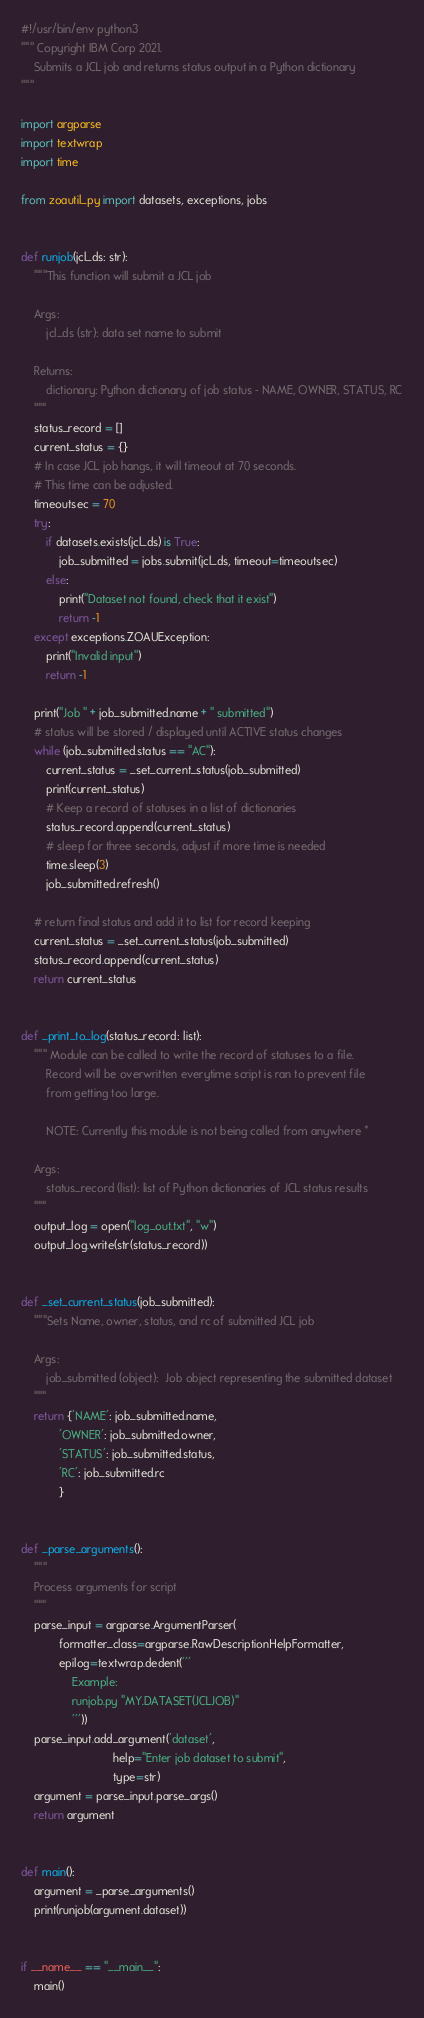Convert code to text. <code><loc_0><loc_0><loc_500><loc_500><_Python_>#!/usr/bin/env python3
""" Copyright IBM Corp 2021.
    Submits a JCL job and returns status output in a Python dictionary
"""

import argparse
import textwrap
import time

from zoautil_py import datasets, exceptions, jobs


def runjob(jcl_ds: str):
    """This function will submit a JCL job

    Args:
        jcl_ds (str): data set name to submit

    Returns:
        dictionary: Python dictionary of job status - NAME, OWNER, STATUS, RC
    """
    status_record = []
    current_status = {}
    # In case JCL job hangs, it will timeout at 70 seconds.
    # This time can be adjusted.
    timeoutsec = 70
    try:
        if datasets.exists(jcl_ds) is True:
            job_submitted = jobs.submit(jcl_ds, timeout=timeoutsec)
        else:
            print("Dataset not found, check that it exist")
            return -1
    except exceptions.ZOAUException:
        print("Invalid input")
        return -1

    print("Job " + job_submitted.name + " submitted")
    # status will be stored / displayed until ACTIVE status changes
    while (job_submitted.status == "AC"):
        current_status = _set_current_status(job_submitted)
        print(current_status)
        # Keep a record of statuses in a list of dictionaries
        status_record.append(current_status)
        # sleep for three seconds, adjust if more time is needed
        time.sleep(3)
        job_submitted.refresh()

    # return final status and add it to list for record keeping
    current_status = _set_current_status(job_submitted)
    status_record.append(current_status)
    return current_status


def _print_to_log(status_record: list):
    """ Module can be called to write the record of statuses to a file.
        Record will be overwritten everytime script is ran to prevent file
        from getting too large.

        NOTE: Currently this module is not being called from anywhere *

    Args:
        status_record (list): list of Python dictionaries of JCL status results
    """
    output_log = open("log_out.txt", "w")
    output_log.write(str(status_record))


def _set_current_status(job_submitted):
    """Sets Name, owner, status, and rc of submitted JCL job

    Args:
        job_submitted (object):  Job object representing the submitted dataset
    """
    return {'NAME': job_submitted.name,
            'OWNER': job_submitted.owner,
            'STATUS': job_submitted.status,
            'RC': job_submitted.rc
            }


def _parse_arguments():
    """
    Process arguments for script
    """
    parse_input = argparse.ArgumentParser(
            formatter_class=argparse.RawDescriptionHelpFormatter,
            epilog=textwrap.dedent('''
                Example:
                runjob.py "MY.DATASET(JCLJOB)"
                '''))
    parse_input.add_argument('dataset',
                             help="Enter job dataset to submit",
                             type=str)
    argument = parse_input.parse_args()
    return argument


def main():
    argument = _parse_arguments()
    print(runjob(argument.dataset))


if __name__ == "__main__":
    main()
</code> 